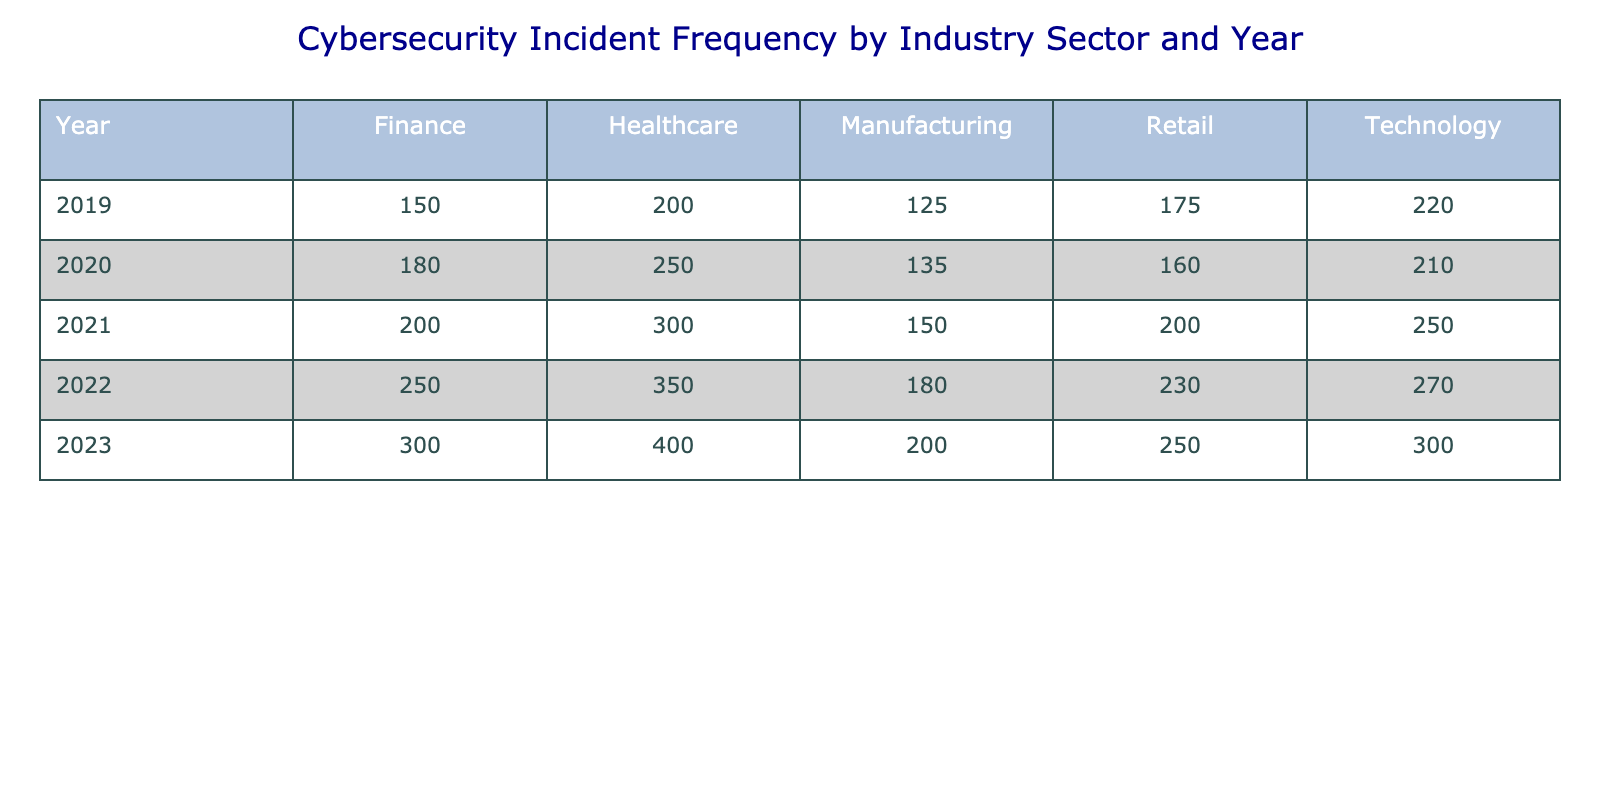What was the highest number of cybersecurity incidents recorded in the Healthcare sector? Referring to the table, the values for Healthcare over the years are 200, 250, 300, 350, and 400. The highest value among these is 400, which was recorded in 2023.
Answer: 400 What was the total number of cybersecurity incidents across all sectors in 2022? To find the total for 2022, add the incidents from all sectors: 250 (Finance) + 350 (Healthcare) + 180 (Manufacturing) + 230 (Retail) + 270 (Technology) = 1280.
Answer: 1280 Did the number of incidents in the Technology sector increase every year from 2019 to 2023? The data for the Technology sector from 2019 to 2023 shows values of 220, 210, 250, 270, and 300. Since the value decreased from 2019 to 2020, the statement is false.
Answer: No Which industry sector experienced the lowest number of incidents in 2021? Checking the incidents for 2021: Finance had 200, Healthcare had 300, Manufacturing had 150, Retail had 200, and Technology had 250. The lowest value is 150 in the Manufacturing sector.
Answer: Manufacturing What was the average number of incidents in the Retail sector from 2019 to 2023? The incidents for Retail are 175, 160, 200, 230, and 250. To find the average, sum these values (175 + 160 + 200 + 230 + 250 = 1015) and divide by the number of years (5), resulting in 1015 / 5 = 203.
Answer: 203 Which year saw the largest increase in incidents for the Finance sector compared to the previous year? The Finance sector recorded incidents of 150 in 2019, 180 in 2020, 200 in 2021, 250 in 2022, and 300 in 2023. The increases from year to year are: 30 (from 2019 to 2020), 20 (2020 to 2021), 50 (2021 to 2022), and 50 (2022 to 2023). The largest increase was 50, from 2021 to 2022, and again from 2022 to 2023.
Answer: 50 Is it true that the number of cybersecurity incidents in the Manufacturing sector exceeded those in the Retail sector in any year from 2019 to 2023? Comparing the values: Manufacturing had 125, 135, 150, 180, and 200 while Retail had 175, 160, 200, 230, and 250. In all years, Manufacturing did not exceed the incidents of the Retail sector.
Answer: No What was the combined total of cybersecurity incidents in the Finance and Technology sectors in 2020? For 2020, the Finance sector had 180 and the Technology sector had 210. The total for both sectors is 180 + 210 = 390.
Answer: 390 